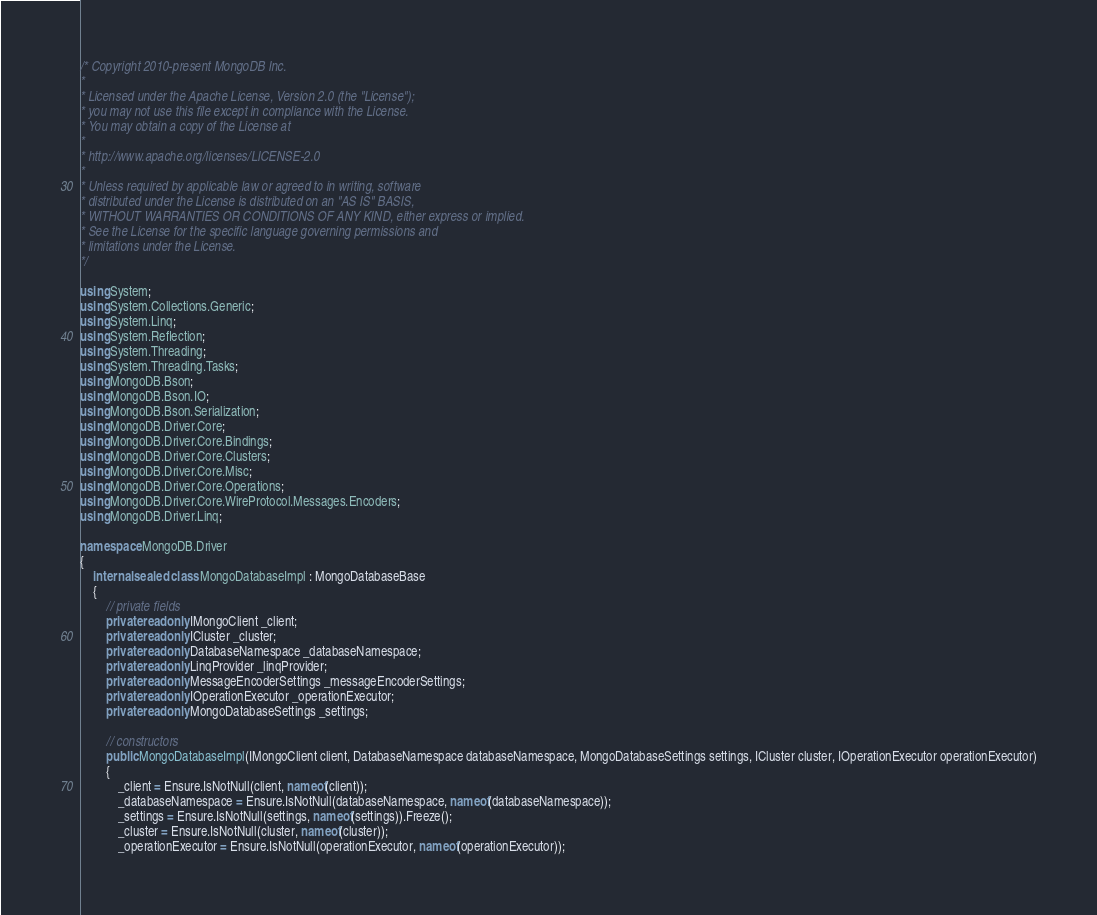<code> <loc_0><loc_0><loc_500><loc_500><_C#_>/* Copyright 2010-present MongoDB Inc.
*
* Licensed under the Apache License, Version 2.0 (the "License");
* you may not use this file except in compliance with the License.
* You may obtain a copy of the License at
*
* http://www.apache.org/licenses/LICENSE-2.0
*
* Unless required by applicable law or agreed to in writing, software
* distributed under the License is distributed on an "AS IS" BASIS,
* WITHOUT WARRANTIES OR CONDITIONS OF ANY KIND, either express or implied.
* See the License for the specific language governing permissions and
* limitations under the License.
*/

using System;
using System.Collections.Generic;
using System.Linq;
using System.Reflection;
using System.Threading;
using System.Threading.Tasks;
using MongoDB.Bson;
using MongoDB.Bson.IO;
using MongoDB.Bson.Serialization;
using MongoDB.Driver.Core;
using MongoDB.Driver.Core.Bindings;
using MongoDB.Driver.Core.Clusters;
using MongoDB.Driver.Core.Misc;
using MongoDB.Driver.Core.Operations;
using MongoDB.Driver.Core.WireProtocol.Messages.Encoders;
using MongoDB.Driver.Linq;

namespace MongoDB.Driver
{
    internal sealed class MongoDatabaseImpl : MongoDatabaseBase
    {
        // private fields
        private readonly IMongoClient _client;
        private readonly ICluster _cluster;
        private readonly DatabaseNamespace _databaseNamespace;
        private readonly LinqProvider _linqProvider;
        private readonly MessageEncoderSettings _messageEncoderSettings;
        private readonly IOperationExecutor _operationExecutor;
        private readonly MongoDatabaseSettings _settings;

        // constructors
        public MongoDatabaseImpl(IMongoClient client, DatabaseNamespace databaseNamespace, MongoDatabaseSettings settings, ICluster cluster, IOperationExecutor operationExecutor)
        {
            _client = Ensure.IsNotNull(client, nameof(client));
            _databaseNamespace = Ensure.IsNotNull(databaseNamespace, nameof(databaseNamespace));
            _settings = Ensure.IsNotNull(settings, nameof(settings)).Freeze();
            _cluster = Ensure.IsNotNull(cluster, nameof(cluster));
            _operationExecutor = Ensure.IsNotNull(operationExecutor, nameof(operationExecutor));
</code> 